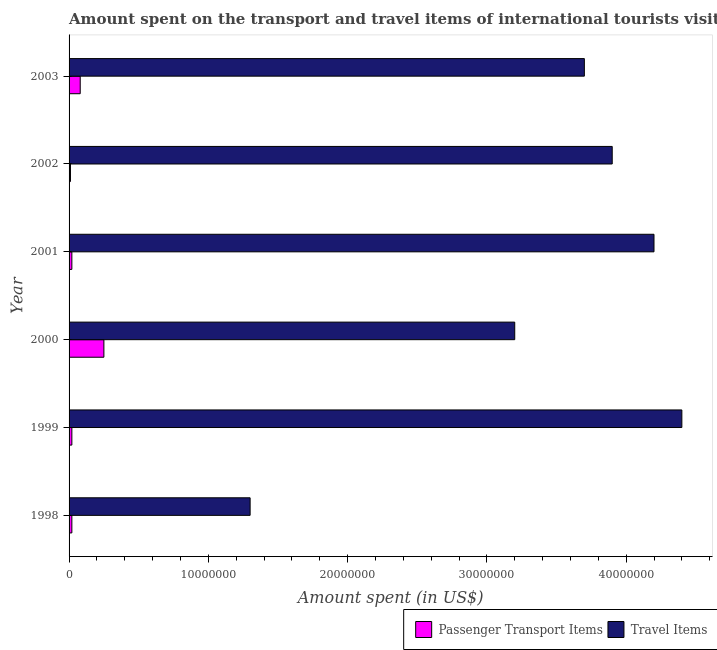How many different coloured bars are there?
Make the answer very short. 2. Are the number of bars on each tick of the Y-axis equal?
Provide a succinct answer. Yes. What is the label of the 2nd group of bars from the top?
Your answer should be compact. 2002. In how many cases, is the number of bars for a given year not equal to the number of legend labels?
Ensure brevity in your answer.  0. What is the amount spent in travel items in 2003?
Your response must be concise. 3.70e+07. Across all years, what is the maximum amount spent in travel items?
Your answer should be compact. 4.40e+07. Across all years, what is the minimum amount spent in travel items?
Offer a terse response. 1.30e+07. In which year was the amount spent on passenger transport items maximum?
Your answer should be compact. 2000. In which year was the amount spent on passenger transport items minimum?
Your response must be concise. 2002. What is the total amount spent on passenger transport items in the graph?
Your answer should be very brief. 4.00e+06. What is the difference between the amount spent in travel items in 2001 and that in 2003?
Give a very brief answer. 5.00e+06. What is the difference between the amount spent in travel items in 1999 and the amount spent on passenger transport items in 1998?
Keep it short and to the point. 4.38e+07. What is the average amount spent on passenger transport items per year?
Keep it short and to the point. 6.67e+05. In the year 2003, what is the difference between the amount spent on passenger transport items and amount spent in travel items?
Give a very brief answer. -3.62e+07. In how many years, is the amount spent in travel items greater than 28000000 US$?
Make the answer very short. 5. What is the ratio of the amount spent in travel items in 1999 to that in 2000?
Make the answer very short. 1.38. Is the amount spent in travel items in 1999 less than that in 2001?
Your answer should be very brief. No. What is the difference between the highest and the second highest amount spent on passenger transport items?
Your answer should be compact. 1.70e+06. What is the difference between the highest and the lowest amount spent in travel items?
Your response must be concise. 3.10e+07. In how many years, is the amount spent in travel items greater than the average amount spent in travel items taken over all years?
Make the answer very short. 4. What does the 2nd bar from the top in 1998 represents?
Your answer should be very brief. Passenger Transport Items. What does the 2nd bar from the bottom in 2003 represents?
Provide a short and direct response. Travel Items. How many bars are there?
Your answer should be compact. 12. How many years are there in the graph?
Your response must be concise. 6. What is the difference between two consecutive major ticks on the X-axis?
Ensure brevity in your answer.  1.00e+07. Are the values on the major ticks of X-axis written in scientific E-notation?
Make the answer very short. No. Does the graph contain grids?
Your answer should be compact. No. Where does the legend appear in the graph?
Provide a succinct answer. Bottom right. How are the legend labels stacked?
Make the answer very short. Horizontal. What is the title of the graph?
Offer a terse response. Amount spent on the transport and travel items of international tourists visited in Sierra Leone. Does "Unregistered firms" appear as one of the legend labels in the graph?
Keep it short and to the point. No. What is the label or title of the X-axis?
Ensure brevity in your answer.  Amount spent (in US$). What is the Amount spent (in US$) of Passenger Transport Items in 1998?
Give a very brief answer. 2.00e+05. What is the Amount spent (in US$) in Travel Items in 1998?
Your answer should be very brief. 1.30e+07. What is the Amount spent (in US$) of Travel Items in 1999?
Your answer should be very brief. 4.40e+07. What is the Amount spent (in US$) in Passenger Transport Items in 2000?
Keep it short and to the point. 2.50e+06. What is the Amount spent (in US$) of Travel Items in 2000?
Give a very brief answer. 3.20e+07. What is the Amount spent (in US$) in Passenger Transport Items in 2001?
Your response must be concise. 2.00e+05. What is the Amount spent (in US$) in Travel Items in 2001?
Offer a very short reply. 4.20e+07. What is the Amount spent (in US$) in Travel Items in 2002?
Your response must be concise. 3.90e+07. What is the Amount spent (in US$) of Passenger Transport Items in 2003?
Provide a succinct answer. 8.00e+05. What is the Amount spent (in US$) in Travel Items in 2003?
Offer a very short reply. 3.70e+07. Across all years, what is the maximum Amount spent (in US$) of Passenger Transport Items?
Provide a succinct answer. 2.50e+06. Across all years, what is the maximum Amount spent (in US$) in Travel Items?
Offer a terse response. 4.40e+07. Across all years, what is the minimum Amount spent (in US$) in Passenger Transport Items?
Give a very brief answer. 1.00e+05. Across all years, what is the minimum Amount spent (in US$) in Travel Items?
Give a very brief answer. 1.30e+07. What is the total Amount spent (in US$) of Passenger Transport Items in the graph?
Provide a short and direct response. 4.00e+06. What is the total Amount spent (in US$) in Travel Items in the graph?
Make the answer very short. 2.07e+08. What is the difference between the Amount spent (in US$) in Travel Items in 1998 and that in 1999?
Your answer should be very brief. -3.10e+07. What is the difference between the Amount spent (in US$) of Passenger Transport Items in 1998 and that in 2000?
Provide a short and direct response. -2.30e+06. What is the difference between the Amount spent (in US$) of Travel Items in 1998 and that in 2000?
Give a very brief answer. -1.90e+07. What is the difference between the Amount spent (in US$) in Passenger Transport Items in 1998 and that in 2001?
Offer a terse response. 0. What is the difference between the Amount spent (in US$) in Travel Items in 1998 and that in 2001?
Your answer should be compact. -2.90e+07. What is the difference between the Amount spent (in US$) of Travel Items in 1998 and that in 2002?
Make the answer very short. -2.60e+07. What is the difference between the Amount spent (in US$) in Passenger Transport Items in 1998 and that in 2003?
Your response must be concise. -6.00e+05. What is the difference between the Amount spent (in US$) of Travel Items in 1998 and that in 2003?
Provide a short and direct response. -2.40e+07. What is the difference between the Amount spent (in US$) of Passenger Transport Items in 1999 and that in 2000?
Ensure brevity in your answer.  -2.30e+06. What is the difference between the Amount spent (in US$) in Travel Items in 1999 and that in 2001?
Your answer should be very brief. 2.00e+06. What is the difference between the Amount spent (in US$) in Passenger Transport Items in 1999 and that in 2002?
Your answer should be compact. 1.00e+05. What is the difference between the Amount spent (in US$) of Travel Items in 1999 and that in 2002?
Provide a succinct answer. 5.00e+06. What is the difference between the Amount spent (in US$) in Passenger Transport Items in 1999 and that in 2003?
Provide a short and direct response. -6.00e+05. What is the difference between the Amount spent (in US$) in Travel Items in 1999 and that in 2003?
Provide a short and direct response. 7.00e+06. What is the difference between the Amount spent (in US$) in Passenger Transport Items in 2000 and that in 2001?
Make the answer very short. 2.30e+06. What is the difference between the Amount spent (in US$) in Travel Items in 2000 and that in 2001?
Ensure brevity in your answer.  -1.00e+07. What is the difference between the Amount spent (in US$) of Passenger Transport Items in 2000 and that in 2002?
Your answer should be very brief. 2.40e+06. What is the difference between the Amount spent (in US$) of Travel Items in 2000 and that in 2002?
Ensure brevity in your answer.  -7.00e+06. What is the difference between the Amount spent (in US$) of Passenger Transport Items in 2000 and that in 2003?
Ensure brevity in your answer.  1.70e+06. What is the difference between the Amount spent (in US$) of Travel Items in 2000 and that in 2003?
Ensure brevity in your answer.  -5.00e+06. What is the difference between the Amount spent (in US$) in Passenger Transport Items in 2001 and that in 2002?
Your answer should be compact. 1.00e+05. What is the difference between the Amount spent (in US$) of Travel Items in 2001 and that in 2002?
Your answer should be compact. 3.00e+06. What is the difference between the Amount spent (in US$) in Passenger Transport Items in 2001 and that in 2003?
Make the answer very short. -6.00e+05. What is the difference between the Amount spent (in US$) in Passenger Transport Items in 2002 and that in 2003?
Ensure brevity in your answer.  -7.00e+05. What is the difference between the Amount spent (in US$) of Passenger Transport Items in 1998 and the Amount spent (in US$) of Travel Items in 1999?
Keep it short and to the point. -4.38e+07. What is the difference between the Amount spent (in US$) in Passenger Transport Items in 1998 and the Amount spent (in US$) in Travel Items in 2000?
Your response must be concise. -3.18e+07. What is the difference between the Amount spent (in US$) in Passenger Transport Items in 1998 and the Amount spent (in US$) in Travel Items in 2001?
Offer a very short reply. -4.18e+07. What is the difference between the Amount spent (in US$) in Passenger Transport Items in 1998 and the Amount spent (in US$) in Travel Items in 2002?
Offer a very short reply. -3.88e+07. What is the difference between the Amount spent (in US$) in Passenger Transport Items in 1998 and the Amount spent (in US$) in Travel Items in 2003?
Your answer should be compact. -3.68e+07. What is the difference between the Amount spent (in US$) of Passenger Transport Items in 1999 and the Amount spent (in US$) of Travel Items in 2000?
Ensure brevity in your answer.  -3.18e+07. What is the difference between the Amount spent (in US$) of Passenger Transport Items in 1999 and the Amount spent (in US$) of Travel Items in 2001?
Make the answer very short. -4.18e+07. What is the difference between the Amount spent (in US$) in Passenger Transport Items in 1999 and the Amount spent (in US$) in Travel Items in 2002?
Offer a very short reply. -3.88e+07. What is the difference between the Amount spent (in US$) of Passenger Transport Items in 1999 and the Amount spent (in US$) of Travel Items in 2003?
Your response must be concise. -3.68e+07. What is the difference between the Amount spent (in US$) in Passenger Transport Items in 2000 and the Amount spent (in US$) in Travel Items in 2001?
Make the answer very short. -3.95e+07. What is the difference between the Amount spent (in US$) of Passenger Transport Items in 2000 and the Amount spent (in US$) of Travel Items in 2002?
Your response must be concise. -3.65e+07. What is the difference between the Amount spent (in US$) of Passenger Transport Items in 2000 and the Amount spent (in US$) of Travel Items in 2003?
Your answer should be compact. -3.45e+07. What is the difference between the Amount spent (in US$) in Passenger Transport Items in 2001 and the Amount spent (in US$) in Travel Items in 2002?
Give a very brief answer. -3.88e+07. What is the difference between the Amount spent (in US$) of Passenger Transport Items in 2001 and the Amount spent (in US$) of Travel Items in 2003?
Ensure brevity in your answer.  -3.68e+07. What is the difference between the Amount spent (in US$) of Passenger Transport Items in 2002 and the Amount spent (in US$) of Travel Items in 2003?
Provide a succinct answer. -3.69e+07. What is the average Amount spent (in US$) in Passenger Transport Items per year?
Ensure brevity in your answer.  6.67e+05. What is the average Amount spent (in US$) in Travel Items per year?
Provide a succinct answer. 3.45e+07. In the year 1998, what is the difference between the Amount spent (in US$) in Passenger Transport Items and Amount spent (in US$) in Travel Items?
Make the answer very short. -1.28e+07. In the year 1999, what is the difference between the Amount spent (in US$) of Passenger Transport Items and Amount spent (in US$) of Travel Items?
Your response must be concise. -4.38e+07. In the year 2000, what is the difference between the Amount spent (in US$) in Passenger Transport Items and Amount spent (in US$) in Travel Items?
Provide a short and direct response. -2.95e+07. In the year 2001, what is the difference between the Amount spent (in US$) of Passenger Transport Items and Amount spent (in US$) of Travel Items?
Offer a terse response. -4.18e+07. In the year 2002, what is the difference between the Amount spent (in US$) of Passenger Transport Items and Amount spent (in US$) of Travel Items?
Provide a succinct answer. -3.89e+07. In the year 2003, what is the difference between the Amount spent (in US$) in Passenger Transport Items and Amount spent (in US$) in Travel Items?
Your answer should be compact. -3.62e+07. What is the ratio of the Amount spent (in US$) of Passenger Transport Items in 1998 to that in 1999?
Make the answer very short. 1. What is the ratio of the Amount spent (in US$) of Travel Items in 1998 to that in 1999?
Your answer should be compact. 0.3. What is the ratio of the Amount spent (in US$) in Travel Items in 1998 to that in 2000?
Your answer should be compact. 0.41. What is the ratio of the Amount spent (in US$) in Passenger Transport Items in 1998 to that in 2001?
Offer a terse response. 1. What is the ratio of the Amount spent (in US$) in Travel Items in 1998 to that in 2001?
Give a very brief answer. 0.31. What is the ratio of the Amount spent (in US$) of Passenger Transport Items in 1998 to that in 2002?
Ensure brevity in your answer.  2. What is the ratio of the Amount spent (in US$) of Travel Items in 1998 to that in 2002?
Give a very brief answer. 0.33. What is the ratio of the Amount spent (in US$) in Passenger Transport Items in 1998 to that in 2003?
Your answer should be very brief. 0.25. What is the ratio of the Amount spent (in US$) of Travel Items in 1998 to that in 2003?
Make the answer very short. 0.35. What is the ratio of the Amount spent (in US$) of Passenger Transport Items in 1999 to that in 2000?
Offer a very short reply. 0.08. What is the ratio of the Amount spent (in US$) of Travel Items in 1999 to that in 2000?
Offer a very short reply. 1.38. What is the ratio of the Amount spent (in US$) in Travel Items in 1999 to that in 2001?
Provide a succinct answer. 1.05. What is the ratio of the Amount spent (in US$) in Passenger Transport Items in 1999 to that in 2002?
Your response must be concise. 2. What is the ratio of the Amount spent (in US$) of Travel Items in 1999 to that in 2002?
Make the answer very short. 1.13. What is the ratio of the Amount spent (in US$) of Travel Items in 1999 to that in 2003?
Your answer should be compact. 1.19. What is the ratio of the Amount spent (in US$) in Passenger Transport Items in 2000 to that in 2001?
Keep it short and to the point. 12.5. What is the ratio of the Amount spent (in US$) in Travel Items in 2000 to that in 2001?
Your answer should be compact. 0.76. What is the ratio of the Amount spent (in US$) of Passenger Transport Items in 2000 to that in 2002?
Your answer should be very brief. 25. What is the ratio of the Amount spent (in US$) of Travel Items in 2000 to that in 2002?
Your response must be concise. 0.82. What is the ratio of the Amount spent (in US$) of Passenger Transport Items in 2000 to that in 2003?
Your answer should be very brief. 3.12. What is the ratio of the Amount spent (in US$) of Travel Items in 2000 to that in 2003?
Your response must be concise. 0.86. What is the ratio of the Amount spent (in US$) in Travel Items in 2001 to that in 2003?
Offer a terse response. 1.14. What is the ratio of the Amount spent (in US$) of Travel Items in 2002 to that in 2003?
Provide a short and direct response. 1.05. What is the difference between the highest and the second highest Amount spent (in US$) of Passenger Transport Items?
Offer a terse response. 1.70e+06. What is the difference between the highest and the lowest Amount spent (in US$) in Passenger Transport Items?
Ensure brevity in your answer.  2.40e+06. What is the difference between the highest and the lowest Amount spent (in US$) of Travel Items?
Make the answer very short. 3.10e+07. 